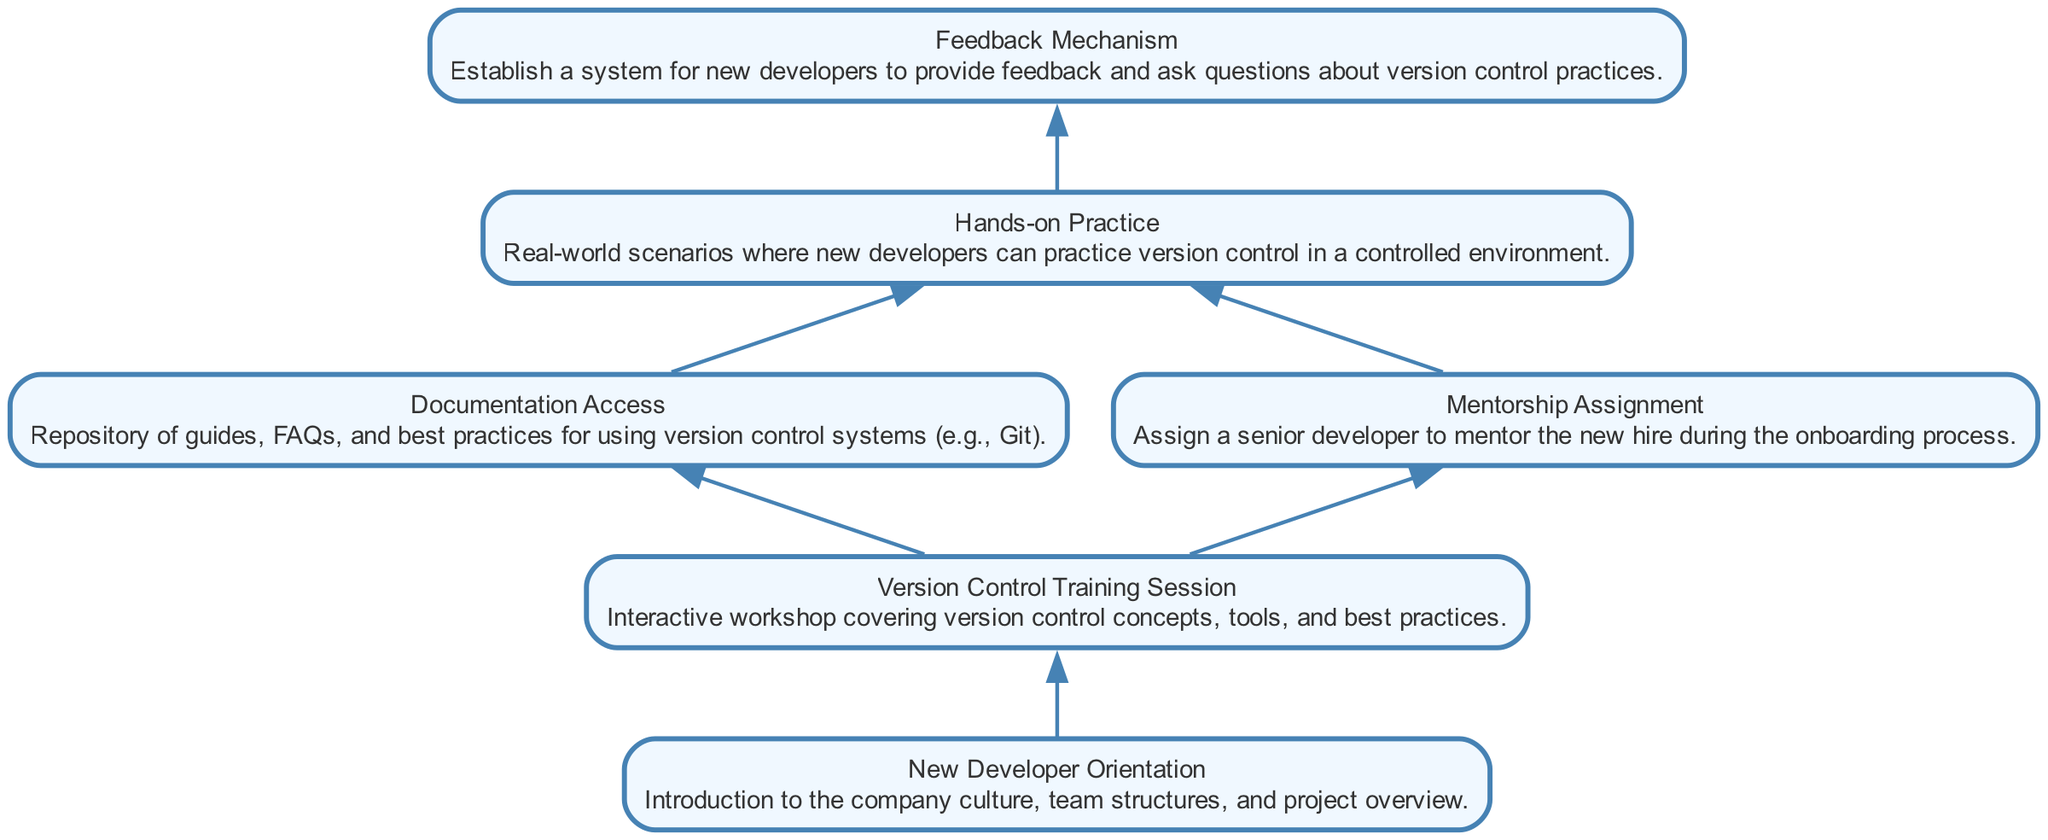What is the first step in the onboarding process? The first step indicated in the diagram is "New Developer Orientation", which introduces the new developers to the company culture, team structures, and project overview.
Answer: New Developer Orientation How many training sessions are offered? The diagram specifies "Version Control Training Session", which is one training session covering version control concepts, tools, and best practices.
Answer: One What is the purpose of the "Hands-on Practice" node? "Hands-on Practice" provides new developers with real-world scenarios to practice version control in a controlled environment, thereby enhancing their training experience.
Answer: Practice scenarios Which element provides documentation access? The "Documentation Access" element is clearly labeled as providing a repository of guides, FAQs, and best practices for using version control systems.
Answer: Documentation Access What is established after the "Version Control Training Session"? The diagram shows that "Documentation Access" and "Mentorship Assignment" both stem from the "Version Control Training Session" node, indicating two outcomes.
Answer: Two outcomes How does "Feedback Mechanism" relate to the onboarding process? "Feedback Mechanism" acts as the final step where new developers can provide feedback and ask questions about their experiences with version control practices, contributing to the overall onboarding process.
Answer: Final step What role does the "Mentorship Assignment" play? It assigns a senior developer to mentor the new hire during the onboarding process, ensuring personalized guidance and support.
Answer: Mentorship role What is the relationship between "Documentation Access" and "Hands-on Practice"? The diagram shows that "Documentation Access" leads to "Hands-on Practice", implying that access to documentation precedes the practical application of learned concepts.
Answer: Sequential relationship Which elements directly link to hands-on practice? "Hands-on Practice" is directly linked to both "Documentation Access" and "Mentorship Assignment", indicating that resources and mentorship aid the practice.
Answer: Two elements 